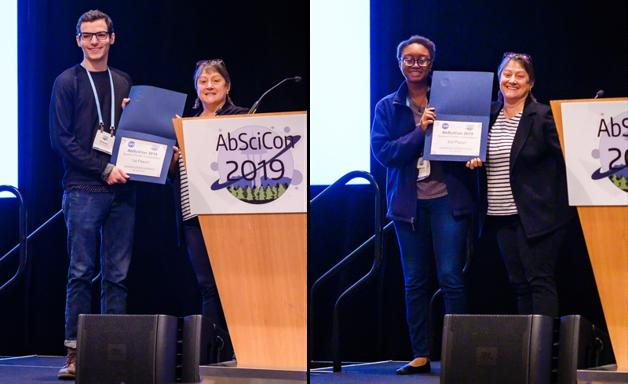Are the people in the photo receiving awards or recognition? Yes, the individuals shown in the photo on stage are indeed receiving awards or recognition. They are likely being honored for their outstanding contributions to the field of astrobiology, reflecting their commitment and innovative research. Each recipient holds a certificate, symbolizing their achievements celebrated during AbSciCon 2019. 